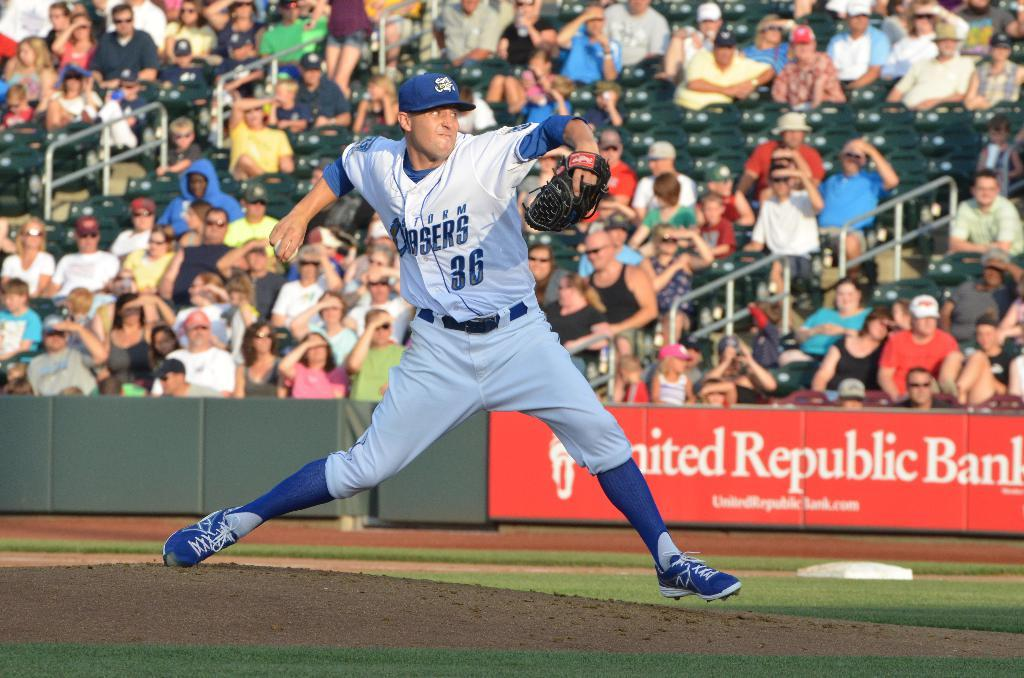<image>
Offer a succinct explanation of the picture presented. The baseball pitcher is wearing the number 36 